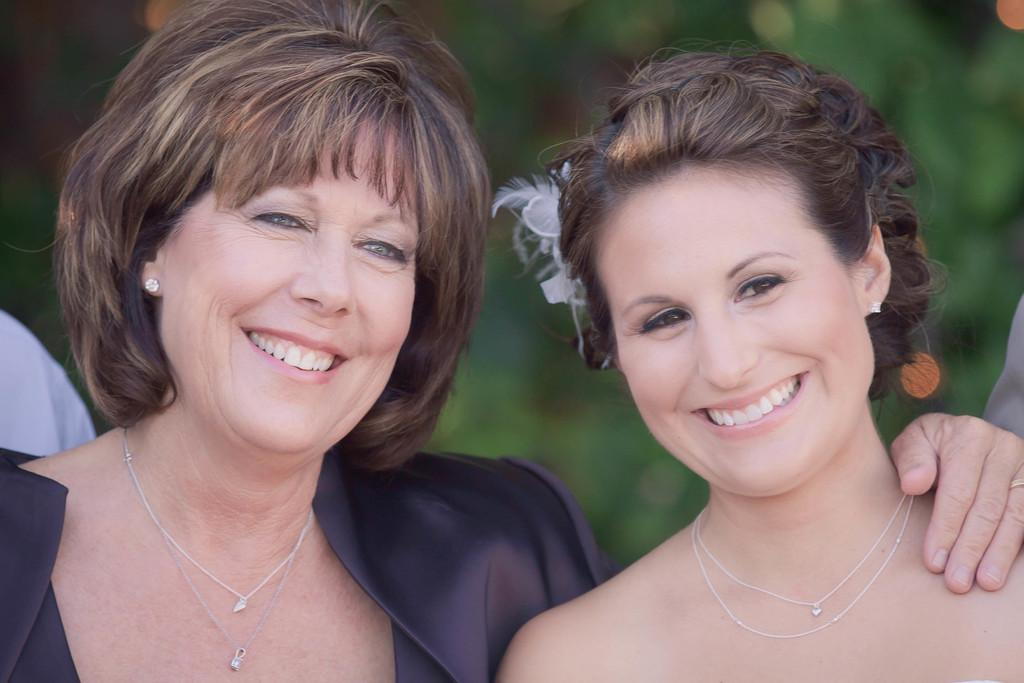How many people are in the image? There are two women in the image. What is the facial expression of the women? Both women are smiling. What type of accessory are the women wearing around their necks? The women are wearing chains around their necks. What color is the background of the image? The background of the image is green. What type of meal are the women preparing in the image? There is no meal preparation visible in the image; it only shows two women smiling and wearing chains around their necks. What scientific experiment is being conducted in the image? There is no scientific experiment depicted in the image. 